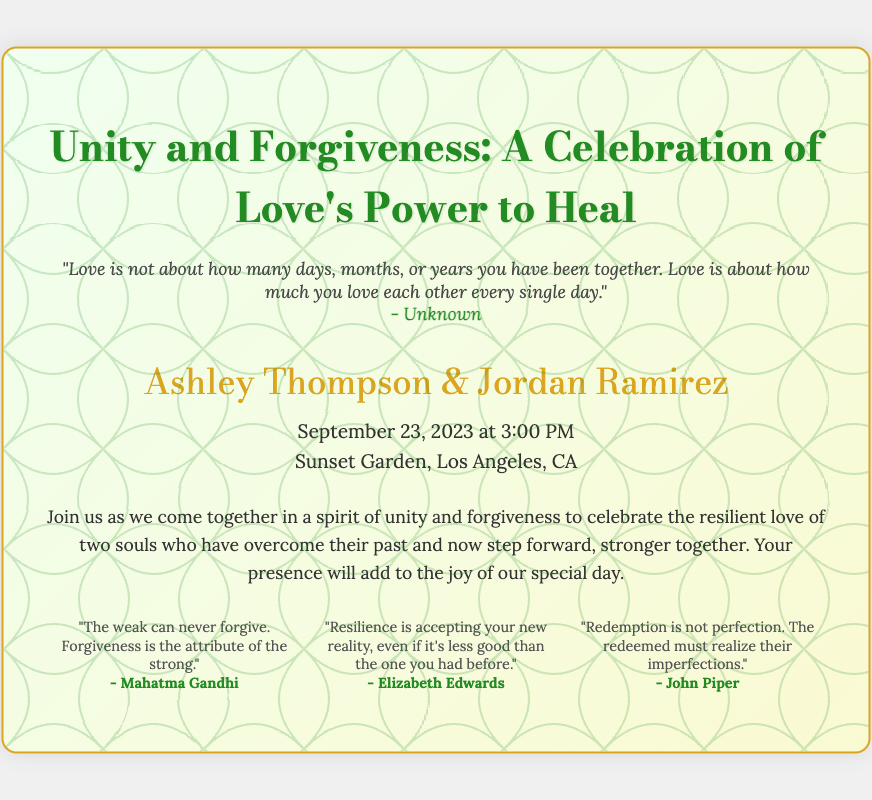What is the title of the wedding invitation? The title of the wedding invitation is prominently displayed at the top of the document.
Answer: Unity and Forgiveness: A Celebration of Love's Power to Heal Who are the couple getting married? The names of the couple getting married are highlighted in the details section of the invitation.
Answer: Ashley Thompson & Jordan Ramirez When is the wedding scheduled? The date and time of the wedding are provided in the details section under the couple's names.
Answer: September 23, 2023 at 3:00 PM Where will the wedding take place? The venue information is specified in the details section of the invitation.
Answer: Sunset Garden, Los Angeles, CA What is the main theme of the invitation? The theme of the invitation can be inferred from the title and message included in the document.
Answer: Unity and Forgiveness Who is quoted as saying "Forgiveness is the attribute of the strong"? This quote is part of the footer section and attributes are noted to the speakers.
Answer: Mahatma Gandhi What is the purpose of this invitation? The purpose is expressed in the message section and reflects the overall tone of the invitation.
Answer: To celebrate love's power to heal What design element is used for the background? The style of the wedding invitation includes artistic design elements, one of which is mentioned in the code.
Answer: Vines What quote reflects resilience in the footer? The footer contains quotes that emphasize resilience, with one specifically addressing this topic.
Answer: "Resilience is accepting your new reality, even if it's less good than the one you had before." 